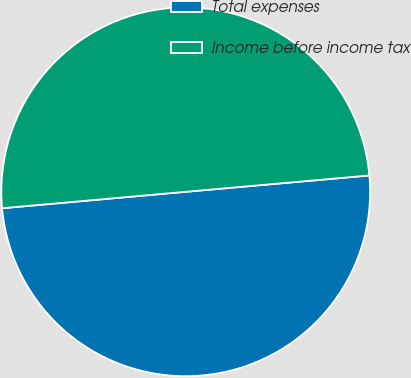Convert chart. <chart><loc_0><loc_0><loc_500><loc_500><pie_chart><fcel>Total expenses<fcel>Income before income tax<nl><fcel>49.99%<fcel>50.01%<nl></chart> 